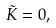Convert formula to latex. <formula><loc_0><loc_0><loc_500><loc_500>\tilde { K } = 0 ,</formula> 